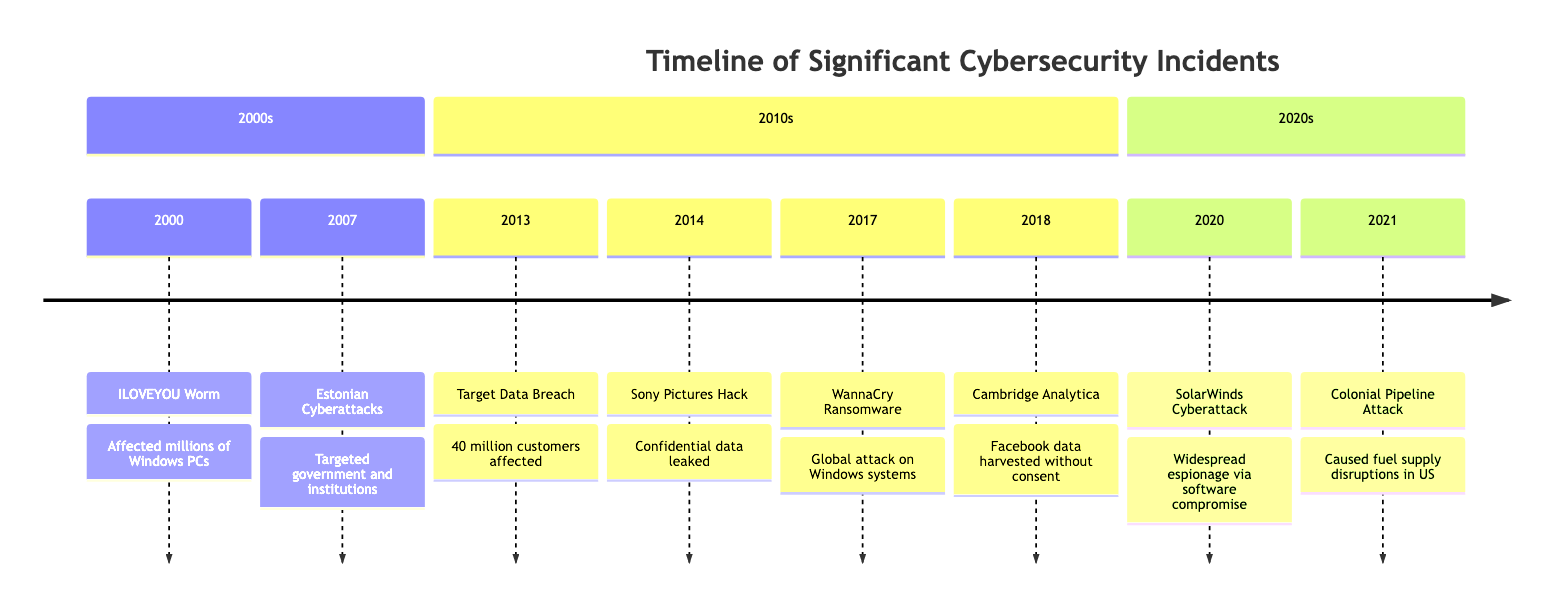What year did the ILOVEYOU Worm incident occur? The diagram indicates that the ILOVEYOU Worm event is associated with the year 2000.
Answer: 2000 Who was affected by the WannaCry Ransomware Attack? The diagram lists several entities affected by the WannaCry Ransomware Attack, including the National Health Service (NHS), Telefónica, FedEx, and Deutsche Bahn. A concise answer would be "Other Organizations Worldwide" since it encompasses all affected entities.
Answer: Other Organizations Worldwide How many significant cybersecurity incidents are listed for the year 2017? The timeline shows one incident listed for the year 2017, which is the WannaCry Ransomware Attack.
Answer: 1 Which event affected the largest number of individual users? The ILOVEYOU Worm attack affected tens of millions of Windows PCs, making it the event with the largest number of individual users affected.
Answer: ILOVEYOU Worm What important cybersecurity incident involved Cambridge Analytica? According to the timeline, the incident related to Cambridge Analytica is a scandal in 2018 concerning harvested Facebook data for political purposes.
Answer: Cambridge Analytica Scandal How did the Colonial Pipeline Ransomware Attack impact consumers? The diagram states that the attack caused fuel supply disruptions across the Eastern United States, directly affecting consumers.
Answer: Fuel supply disruptions Which significant cyber incident happened first in the 2010s? The Target Data Breach in 2013 is the first incident listed in the 2010s section of the timeline.
Answer: Target Data Breach What is the nature of the SolarWinds Cyberattack? The timeline describes it as a widespread cyber espionage attack, highlighting its covert nature.
Answer: Cyber espionage Which year marks the start of the listed cyber incidents? Reviewing the diagram, the earliest incident is from the year 2000, marked by the ILOVEYOU Worm.
Answer: 2000 What type of organizations were primarily affected by the Estonian Cyberattacks? The diagram indicates that government, financial institutions, and media organizations in Estonia were primarily affected.
Answer: Estonian Government, Financial Institutions, Media 